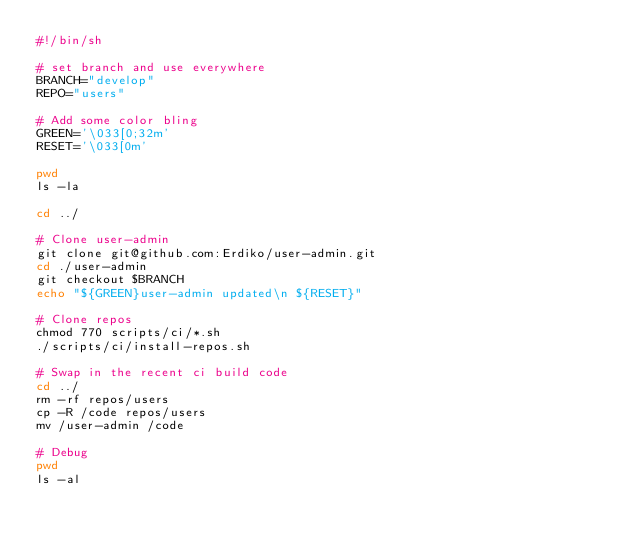<code> <loc_0><loc_0><loc_500><loc_500><_Bash_>#!/bin/sh

# set branch and use everywhere
BRANCH="develop"
REPO="users"

# Add some color bling
GREEN='\033[0;32m'
RESET='\033[0m'

pwd
ls -la

cd ../

# Clone user-admin
git clone git@github.com:Erdiko/user-admin.git
cd ./user-admin
git checkout $BRANCH
echo "${GREEN}user-admin updated\n ${RESET}"

# Clone repos
chmod 770 scripts/ci/*.sh
./scripts/ci/install-repos.sh

# Swap in the recent ci build code
cd ../
rm -rf repos/users
cp -R /code repos/users
mv /user-admin /code

# Debug
pwd
ls -al
</code> 